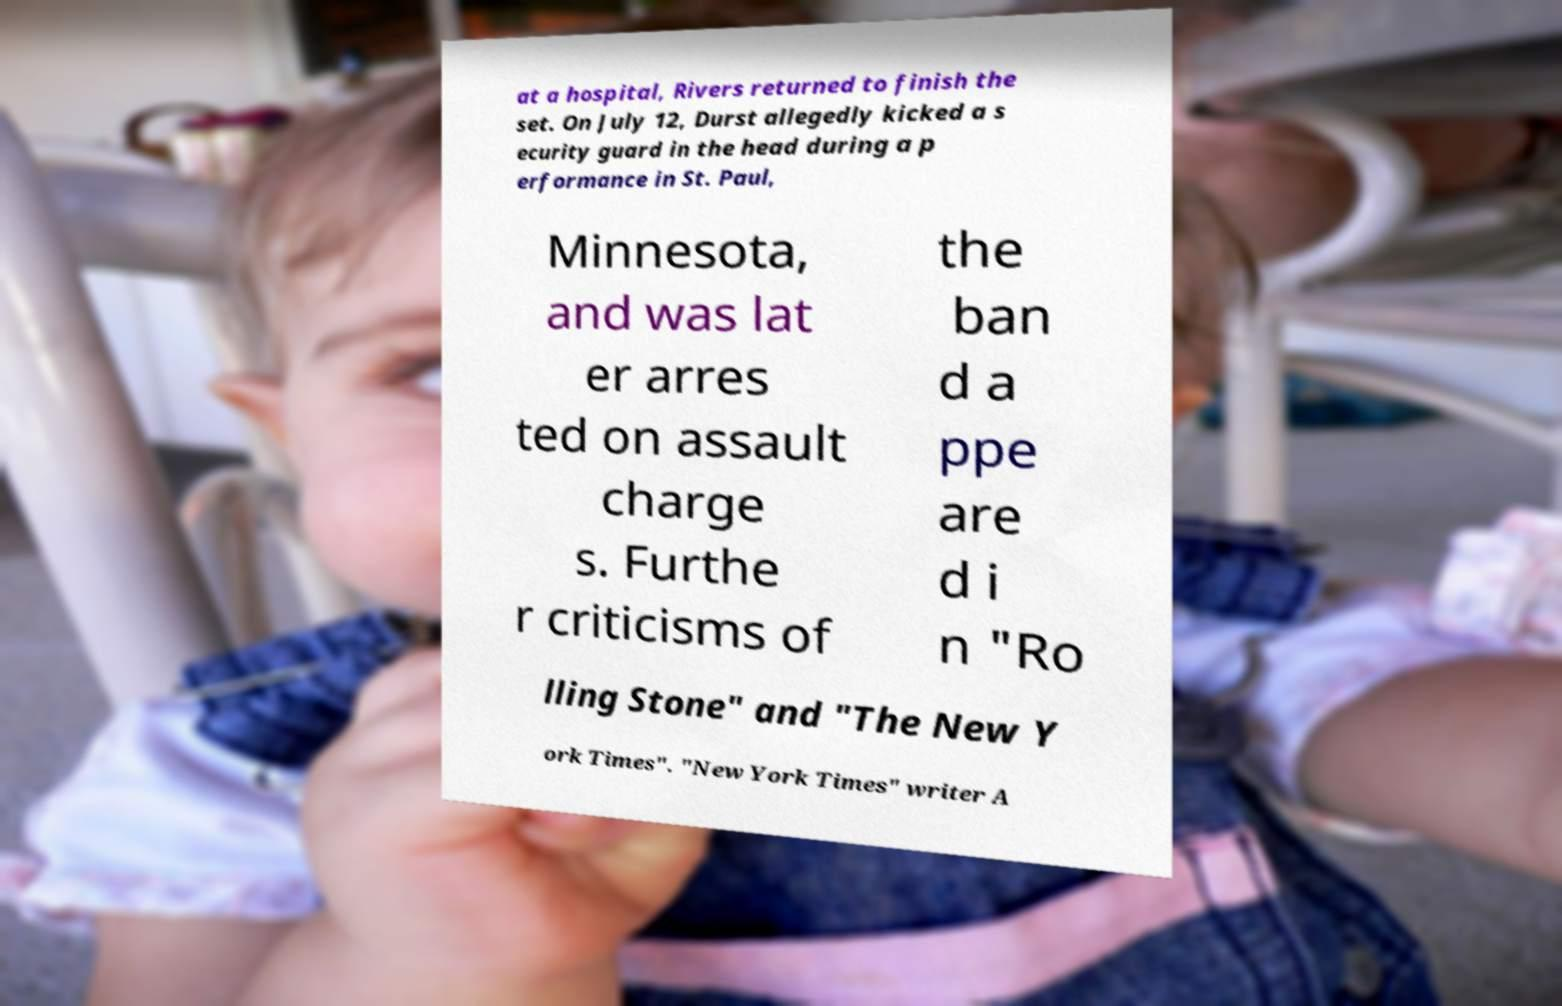Please read and relay the text visible in this image. What does it say? at a hospital, Rivers returned to finish the set. On July 12, Durst allegedly kicked a s ecurity guard in the head during a p erformance in St. Paul, Minnesota, and was lat er arres ted on assault charge s. Furthe r criticisms of the ban d a ppe are d i n "Ro lling Stone" and "The New Y ork Times". "New York Times" writer A 